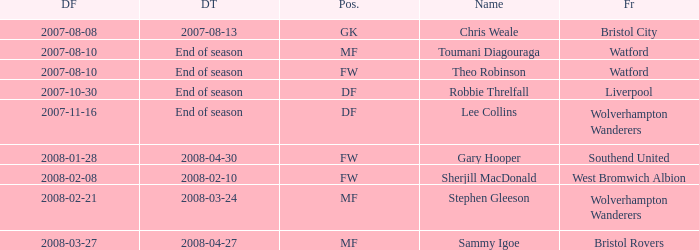Could you help me parse every detail presented in this table? {'header': ['DF', 'DT', 'Pos.', 'Name', 'Fr'], 'rows': [['2007-08-08', '2007-08-13', 'GK', 'Chris Weale', 'Bristol City'], ['2007-08-10', 'End of season', 'MF', 'Toumani Diagouraga', 'Watford'], ['2007-08-10', 'End of season', 'FW', 'Theo Robinson', 'Watford'], ['2007-10-30', 'End of season', 'DF', 'Robbie Threlfall', 'Liverpool'], ['2007-11-16', 'End of season', 'DF', 'Lee Collins', 'Wolverhampton Wanderers'], ['2008-01-28', '2008-04-30', 'FW', 'Gary Hooper', 'Southend United'], ['2008-02-08', '2008-02-10', 'FW', 'Sherjill MacDonald', 'West Bromwich Albion'], ['2008-02-21', '2008-03-24', 'MF', 'Stephen Gleeson', 'Wolverhampton Wanderers'], ['2008-03-27', '2008-04-27', 'MF', 'Sammy Igoe', 'Bristol Rovers']]} What was the from for the Date From of 2007-08-08? Bristol City. 